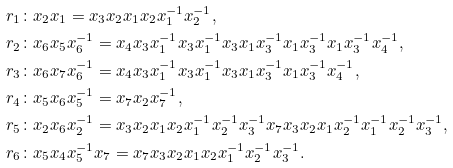Convert formula to latex. <formula><loc_0><loc_0><loc_500><loc_500>r _ { 1 } & \colon x _ { 2 } x _ { 1 } = x _ { 3 } x _ { 2 } x _ { 1 } x _ { 2 } x _ { 1 } ^ { - 1 } x _ { 2 } ^ { - 1 } , \\ r _ { 2 } & \colon x _ { 6 } x _ { 5 } x _ { 6 } ^ { - 1 } = x _ { 4 } x _ { 3 } x _ { 1 } ^ { - 1 } x _ { 3 } x _ { 1 } ^ { - 1 } x _ { 3 } x _ { 1 } x _ { 3 } ^ { - 1 } x _ { 1 } x _ { 3 } ^ { - 1 } x _ { 1 } x _ { 3 } ^ { - 1 } x _ { 4 } ^ { - 1 } , \\ r _ { 3 } & \colon x _ { 6 } x _ { 7 } x _ { 6 } ^ { - 1 } = x _ { 4 } x _ { 3 } x _ { 1 } ^ { - 1 } x _ { 3 } x _ { 1 } ^ { - 1 } x _ { 3 } x _ { 1 } x _ { 3 } ^ { - 1 } x _ { 1 } x _ { 3 } ^ { - 1 } x _ { 4 } ^ { - 1 } , \\ r _ { 4 } & \colon x _ { 5 } x _ { 6 } x _ { 5 } ^ { - 1 } = x _ { 7 } x _ { 2 } x _ { 7 } ^ { - 1 } , \\ r _ { 5 } & \colon x _ { 2 } x _ { 6 } x _ { 2 } ^ { - 1 } = x _ { 3 } x _ { 2 } x _ { 1 } x _ { 2 } x _ { 1 } ^ { - 1 } x _ { 2 } ^ { - 1 } x _ { 3 } ^ { - 1 } x _ { 7 } x _ { 3 } x _ { 2 } x _ { 1 } x _ { 2 } ^ { - 1 } x _ { 1 } ^ { - 1 } x _ { 2 } ^ { - 1 } x _ { 3 } ^ { - 1 } , \\ r _ { 6 } & \colon x _ { 5 } x _ { 4 } x _ { 5 } ^ { - 1 } x _ { 7 } = x _ { 7 } x _ { 3 } x _ { 2 } x _ { 1 } x _ { 2 } x _ { 1 } ^ { - 1 } x _ { 2 } ^ { - 1 } x _ { 3 } ^ { - 1 } .</formula> 